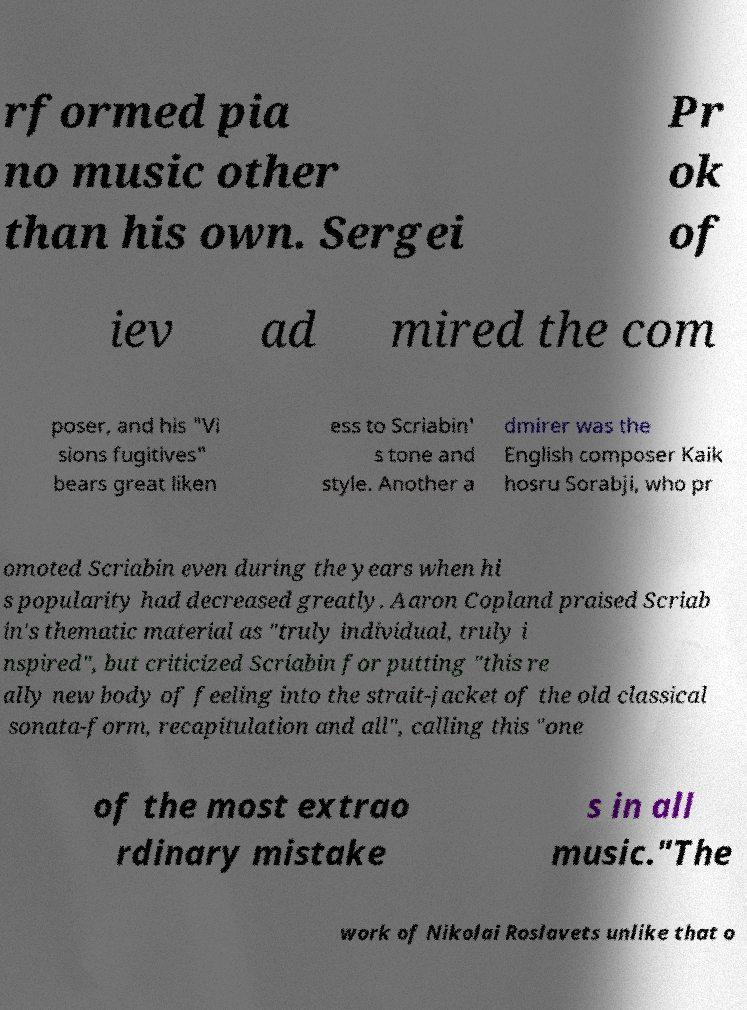Please identify and transcribe the text found in this image. rformed pia no music other than his own. Sergei Pr ok of iev ad mired the com poser, and his "Vi sions fugitives" bears great liken ess to Scriabin' s tone and style. Another a dmirer was the English composer Kaik hosru Sorabji, who pr omoted Scriabin even during the years when hi s popularity had decreased greatly. Aaron Copland praised Scriab in's thematic material as "truly individual, truly i nspired", but criticized Scriabin for putting "this re ally new body of feeling into the strait-jacket of the old classical sonata-form, recapitulation and all", calling this "one of the most extrao rdinary mistake s in all music."The work of Nikolai Roslavets unlike that o 